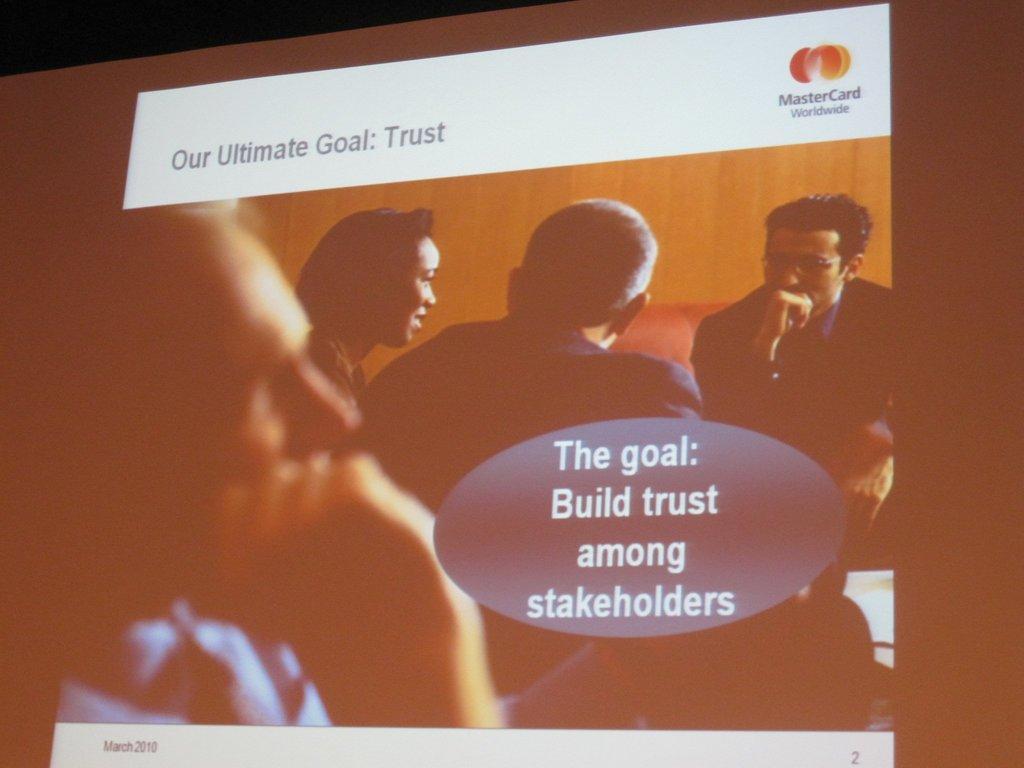Can you describe this image briefly? In this image we can see a screen with some persons and text on it. 